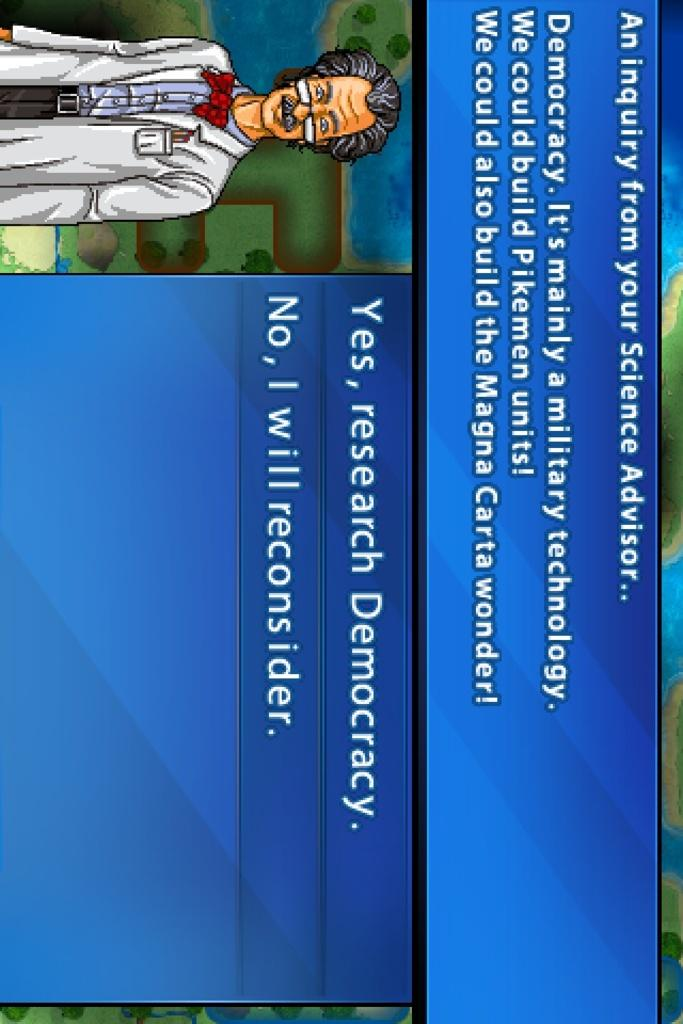Provide a one-sentence caption for the provided image. An computer science advisor is asking whether the viewer wants to research Democracy. 